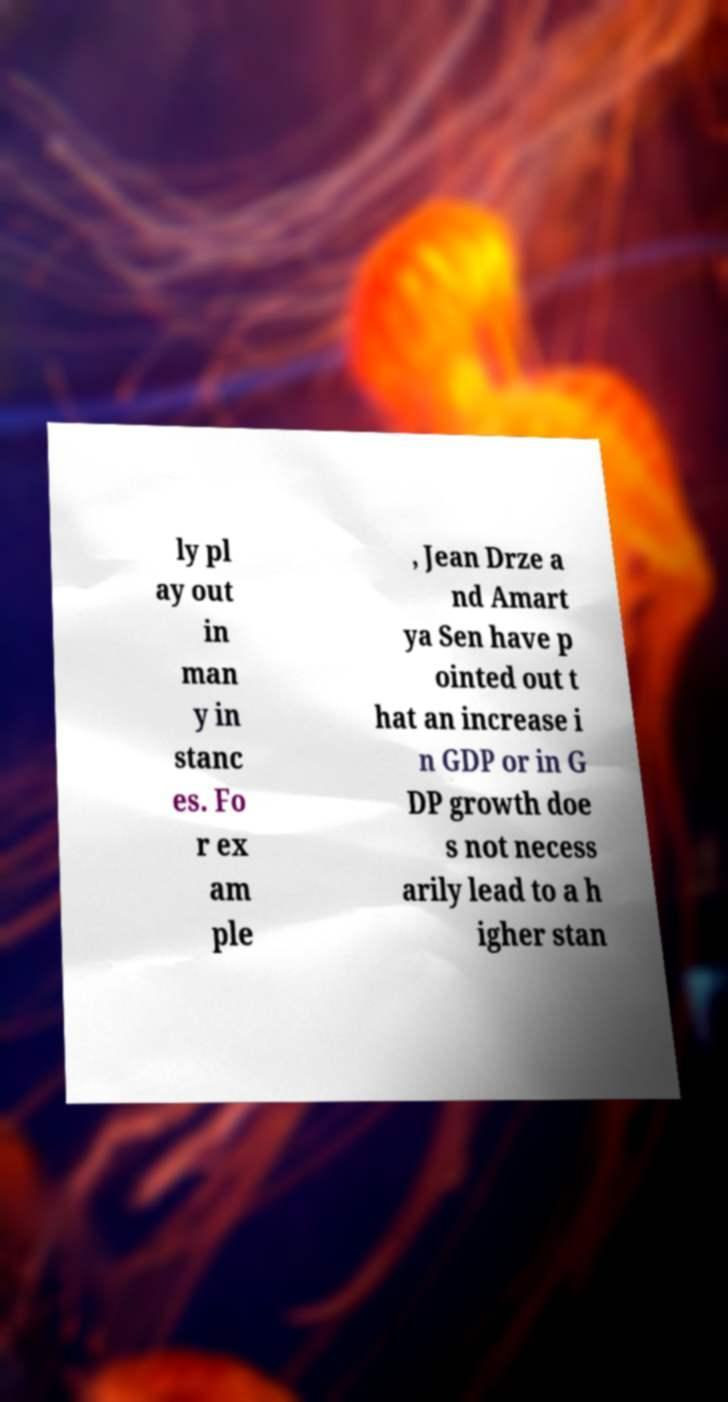I need the written content from this picture converted into text. Can you do that? ly pl ay out in man y in stanc es. Fo r ex am ple , Jean Drze a nd Amart ya Sen have p ointed out t hat an increase i n GDP or in G DP growth doe s not necess arily lead to a h igher stan 